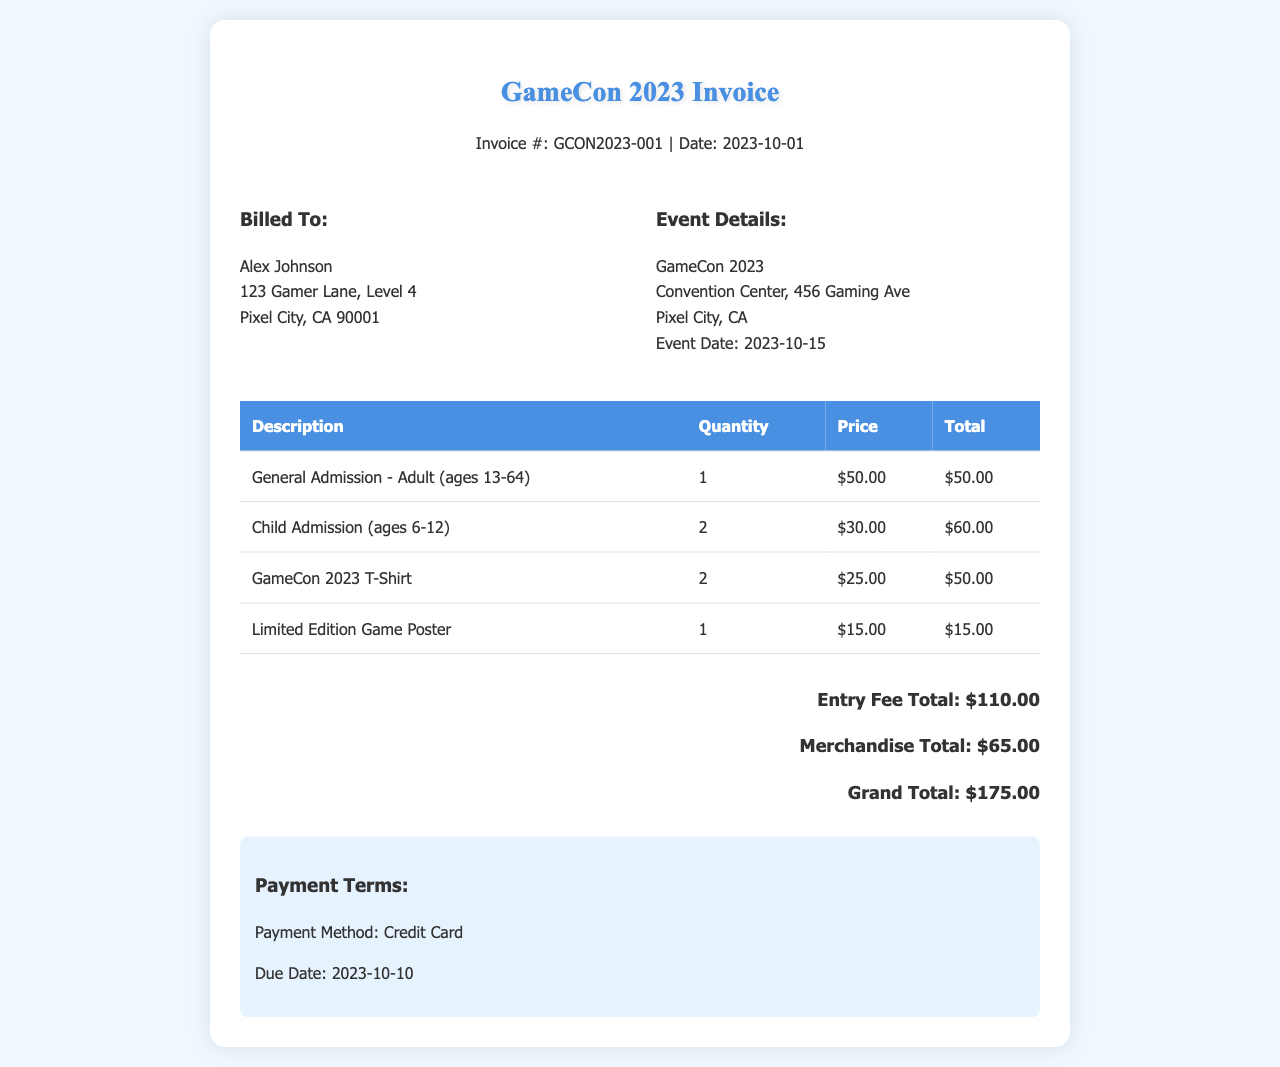what is the event date? The event date is clearly stated in the document under the Event Details section.
Answer: 2023-10-15 how much is the general admission for adults? The price for general admission for adults (ages 13-64) is provided in the price column of the table.
Answer: $50.00 how many child admissions were purchased? The quantity of child admissions is noted in the table under the Quantity column for Child Admission.
Answer: 2 what is the total for merchandise items? The total for merchandise is calculated from the Merchandise Total section of the invoice.
Answer: $65.00 who is billed for this invoice? The name of the person billed can be found in the Billed To section of the document.
Answer: Alex Johnson what is the grand total of the invoice? The grand total is clearly summarized at the end of the total section.
Answer: $175.00 when is the payment due? The due date for payment is specified in the Payment Terms section of the invoice.
Answer: 2023-10-10 how many game posters were purchased? The quantity of Limited Edition Game Posters can be found in the table under the Quantity column for Game Posters.
Answer: 1 what method of payment is accepted? The payment method is listed in the Payment Terms section, stating the chosen method for this invoice.
Answer: Credit Card 